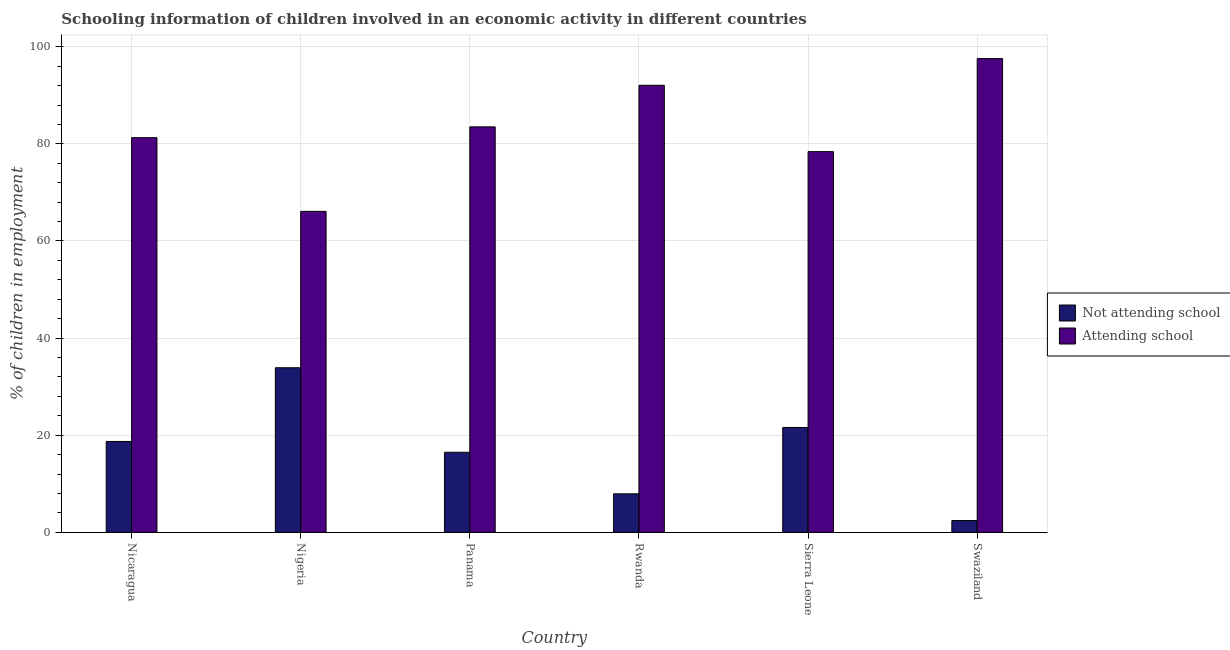How many different coloured bars are there?
Provide a succinct answer. 2. How many bars are there on the 2nd tick from the left?
Provide a short and direct response. 2. What is the label of the 4th group of bars from the left?
Offer a terse response. Rwanda. In how many cases, is the number of bars for a given country not equal to the number of legend labels?
Your answer should be very brief. 0. What is the percentage of employed children who are attending school in Nicaragua?
Keep it short and to the point. 81.27. Across all countries, what is the maximum percentage of employed children who are not attending school?
Offer a terse response. 33.9. Across all countries, what is the minimum percentage of employed children who are attending school?
Your response must be concise. 66.1. In which country was the percentage of employed children who are not attending school maximum?
Your answer should be compact. Nigeria. In which country was the percentage of employed children who are not attending school minimum?
Your answer should be very brief. Swaziland. What is the total percentage of employed children who are attending school in the graph?
Keep it short and to the point. 498.9. What is the difference between the percentage of employed children who are not attending school in Nicaragua and that in Sierra Leone?
Your answer should be compact. -2.87. What is the difference between the percentage of employed children who are not attending school in Sierra Leone and the percentage of employed children who are attending school in Panama?
Keep it short and to the point. -61.9. What is the average percentage of employed children who are attending school per country?
Give a very brief answer. 83.15. What is the difference between the percentage of employed children who are attending school and percentage of employed children who are not attending school in Nigeria?
Provide a short and direct response. 32.2. What is the ratio of the percentage of employed children who are not attending school in Nigeria to that in Sierra Leone?
Provide a short and direct response. 1.57. Is the percentage of employed children who are not attending school in Panama less than that in Swaziland?
Provide a succinct answer. No. Is the difference between the percentage of employed children who are attending school in Sierra Leone and Swaziland greater than the difference between the percentage of employed children who are not attending school in Sierra Leone and Swaziland?
Keep it short and to the point. No. What is the difference between the highest and the second highest percentage of employed children who are not attending school?
Your response must be concise. 12.3. What is the difference between the highest and the lowest percentage of employed children who are not attending school?
Your answer should be compact. 31.46. Is the sum of the percentage of employed children who are not attending school in Nicaragua and Swaziland greater than the maximum percentage of employed children who are attending school across all countries?
Offer a terse response. No. What does the 2nd bar from the left in Nicaragua represents?
Provide a succinct answer. Attending school. What does the 1st bar from the right in Nigeria represents?
Offer a terse response. Attending school. Are all the bars in the graph horizontal?
Give a very brief answer. No. How many countries are there in the graph?
Your answer should be compact. 6. Does the graph contain grids?
Offer a very short reply. Yes. Where does the legend appear in the graph?
Give a very brief answer. Center right. What is the title of the graph?
Your response must be concise. Schooling information of children involved in an economic activity in different countries. Does "Electricity and heat production" appear as one of the legend labels in the graph?
Ensure brevity in your answer.  No. What is the label or title of the X-axis?
Provide a short and direct response. Country. What is the label or title of the Y-axis?
Your answer should be compact. % of children in employment. What is the % of children in employment in Not attending school in Nicaragua?
Offer a terse response. 18.73. What is the % of children in employment of Attending school in Nicaragua?
Your answer should be very brief. 81.27. What is the % of children in employment of Not attending school in Nigeria?
Offer a very short reply. 33.9. What is the % of children in employment in Attending school in Nigeria?
Your answer should be compact. 66.1. What is the % of children in employment of Not attending school in Panama?
Provide a short and direct response. 16.5. What is the % of children in employment in Attending school in Panama?
Make the answer very short. 83.5. What is the % of children in employment in Not attending school in Rwanda?
Ensure brevity in your answer.  7.94. What is the % of children in employment of Attending school in Rwanda?
Provide a short and direct response. 92.06. What is the % of children in employment of Not attending school in Sierra Leone?
Provide a short and direct response. 21.6. What is the % of children in employment in Attending school in Sierra Leone?
Your answer should be compact. 78.4. What is the % of children in employment of Not attending school in Swaziland?
Provide a succinct answer. 2.44. What is the % of children in employment in Attending school in Swaziland?
Your answer should be compact. 97.56. Across all countries, what is the maximum % of children in employment in Not attending school?
Offer a very short reply. 33.9. Across all countries, what is the maximum % of children in employment of Attending school?
Your answer should be compact. 97.56. Across all countries, what is the minimum % of children in employment of Not attending school?
Your response must be concise. 2.44. Across all countries, what is the minimum % of children in employment in Attending school?
Offer a terse response. 66.1. What is the total % of children in employment of Not attending school in the graph?
Your answer should be very brief. 101.1. What is the total % of children in employment in Attending school in the graph?
Keep it short and to the point. 498.9. What is the difference between the % of children in employment in Not attending school in Nicaragua and that in Nigeria?
Your answer should be compact. -15.17. What is the difference between the % of children in employment of Attending school in Nicaragua and that in Nigeria?
Offer a terse response. 15.17. What is the difference between the % of children in employment of Not attending school in Nicaragua and that in Panama?
Your response must be concise. 2.23. What is the difference between the % of children in employment of Attending school in Nicaragua and that in Panama?
Provide a succinct answer. -2.23. What is the difference between the % of children in employment in Not attending school in Nicaragua and that in Rwanda?
Offer a very short reply. 10.79. What is the difference between the % of children in employment of Attending school in Nicaragua and that in Rwanda?
Give a very brief answer. -10.79. What is the difference between the % of children in employment of Not attending school in Nicaragua and that in Sierra Leone?
Offer a very short reply. -2.87. What is the difference between the % of children in employment in Attending school in Nicaragua and that in Sierra Leone?
Your answer should be very brief. 2.87. What is the difference between the % of children in employment in Not attending school in Nicaragua and that in Swaziland?
Your answer should be compact. 16.29. What is the difference between the % of children in employment of Attending school in Nicaragua and that in Swaziland?
Offer a terse response. -16.29. What is the difference between the % of children in employment of Not attending school in Nigeria and that in Panama?
Give a very brief answer. 17.4. What is the difference between the % of children in employment in Attending school in Nigeria and that in Panama?
Provide a short and direct response. -17.4. What is the difference between the % of children in employment of Not attending school in Nigeria and that in Rwanda?
Your answer should be compact. 25.96. What is the difference between the % of children in employment in Attending school in Nigeria and that in Rwanda?
Give a very brief answer. -25.96. What is the difference between the % of children in employment in Not attending school in Nigeria and that in Sierra Leone?
Make the answer very short. 12.3. What is the difference between the % of children in employment of Attending school in Nigeria and that in Sierra Leone?
Provide a short and direct response. -12.3. What is the difference between the % of children in employment of Not attending school in Nigeria and that in Swaziland?
Keep it short and to the point. 31.46. What is the difference between the % of children in employment of Attending school in Nigeria and that in Swaziland?
Ensure brevity in your answer.  -31.46. What is the difference between the % of children in employment of Not attending school in Panama and that in Rwanda?
Ensure brevity in your answer.  8.56. What is the difference between the % of children in employment of Attending school in Panama and that in Rwanda?
Make the answer very short. -8.56. What is the difference between the % of children in employment of Attending school in Panama and that in Sierra Leone?
Offer a very short reply. 5.1. What is the difference between the % of children in employment in Not attending school in Panama and that in Swaziland?
Your response must be concise. 14.06. What is the difference between the % of children in employment in Attending school in Panama and that in Swaziland?
Ensure brevity in your answer.  -14.06. What is the difference between the % of children in employment of Not attending school in Rwanda and that in Sierra Leone?
Keep it short and to the point. -13.66. What is the difference between the % of children in employment in Attending school in Rwanda and that in Sierra Leone?
Offer a terse response. 13.66. What is the difference between the % of children in employment in Not attending school in Rwanda and that in Swaziland?
Provide a short and direct response. 5.5. What is the difference between the % of children in employment in Attending school in Rwanda and that in Swaziland?
Your answer should be very brief. -5.5. What is the difference between the % of children in employment of Not attending school in Sierra Leone and that in Swaziland?
Make the answer very short. 19.16. What is the difference between the % of children in employment of Attending school in Sierra Leone and that in Swaziland?
Provide a short and direct response. -19.16. What is the difference between the % of children in employment of Not attending school in Nicaragua and the % of children in employment of Attending school in Nigeria?
Your answer should be compact. -47.37. What is the difference between the % of children in employment in Not attending school in Nicaragua and the % of children in employment in Attending school in Panama?
Ensure brevity in your answer.  -64.77. What is the difference between the % of children in employment of Not attending school in Nicaragua and the % of children in employment of Attending school in Rwanda?
Your answer should be very brief. -73.34. What is the difference between the % of children in employment in Not attending school in Nicaragua and the % of children in employment in Attending school in Sierra Leone?
Offer a very short reply. -59.67. What is the difference between the % of children in employment in Not attending school in Nicaragua and the % of children in employment in Attending school in Swaziland?
Give a very brief answer. -78.84. What is the difference between the % of children in employment in Not attending school in Nigeria and the % of children in employment in Attending school in Panama?
Your response must be concise. -49.6. What is the difference between the % of children in employment in Not attending school in Nigeria and the % of children in employment in Attending school in Rwanda?
Make the answer very short. -58.16. What is the difference between the % of children in employment of Not attending school in Nigeria and the % of children in employment of Attending school in Sierra Leone?
Ensure brevity in your answer.  -44.5. What is the difference between the % of children in employment in Not attending school in Nigeria and the % of children in employment in Attending school in Swaziland?
Make the answer very short. -63.66. What is the difference between the % of children in employment in Not attending school in Panama and the % of children in employment in Attending school in Rwanda?
Give a very brief answer. -75.56. What is the difference between the % of children in employment in Not attending school in Panama and the % of children in employment in Attending school in Sierra Leone?
Your answer should be very brief. -61.9. What is the difference between the % of children in employment of Not attending school in Panama and the % of children in employment of Attending school in Swaziland?
Offer a terse response. -81.06. What is the difference between the % of children in employment of Not attending school in Rwanda and the % of children in employment of Attending school in Sierra Leone?
Offer a very short reply. -70.46. What is the difference between the % of children in employment in Not attending school in Rwanda and the % of children in employment in Attending school in Swaziland?
Make the answer very short. -89.62. What is the difference between the % of children in employment in Not attending school in Sierra Leone and the % of children in employment in Attending school in Swaziland?
Make the answer very short. -75.96. What is the average % of children in employment in Not attending school per country?
Provide a succinct answer. 16.85. What is the average % of children in employment in Attending school per country?
Make the answer very short. 83.15. What is the difference between the % of children in employment of Not attending school and % of children in employment of Attending school in Nicaragua?
Your answer should be compact. -62.55. What is the difference between the % of children in employment in Not attending school and % of children in employment in Attending school in Nigeria?
Your answer should be compact. -32.2. What is the difference between the % of children in employment in Not attending school and % of children in employment in Attending school in Panama?
Give a very brief answer. -67. What is the difference between the % of children in employment of Not attending school and % of children in employment of Attending school in Rwanda?
Your answer should be very brief. -84.12. What is the difference between the % of children in employment in Not attending school and % of children in employment in Attending school in Sierra Leone?
Make the answer very short. -56.8. What is the difference between the % of children in employment in Not attending school and % of children in employment in Attending school in Swaziland?
Make the answer very short. -95.13. What is the ratio of the % of children in employment in Not attending school in Nicaragua to that in Nigeria?
Keep it short and to the point. 0.55. What is the ratio of the % of children in employment of Attending school in Nicaragua to that in Nigeria?
Offer a very short reply. 1.23. What is the ratio of the % of children in employment in Not attending school in Nicaragua to that in Panama?
Offer a very short reply. 1.13. What is the ratio of the % of children in employment of Attending school in Nicaragua to that in Panama?
Offer a very short reply. 0.97. What is the ratio of the % of children in employment in Not attending school in Nicaragua to that in Rwanda?
Give a very brief answer. 2.36. What is the ratio of the % of children in employment of Attending school in Nicaragua to that in Rwanda?
Provide a short and direct response. 0.88. What is the ratio of the % of children in employment in Not attending school in Nicaragua to that in Sierra Leone?
Provide a succinct answer. 0.87. What is the ratio of the % of children in employment in Attending school in Nicaragua to that in Sierra Leone?
Make the answer very short. 1.04. What is the ratio of the % of children in employment in Not attending school in Nicaragua to that in Swaziland?
Ensure brevity in your answer.  7.69. What is the ratio of the % of children in employment in Attending school in Nicaragua to that in Swaziland?
Give a very brief answer. 0.83. What is the ratio of the % of children in employment in Not attending school in Nigeria to that in Panama?
Give a very brief answer. 2.05. What is the ratio of the % of children in employment in Attending school in Nigeria to that in Panama?
Give a very brief answer. 0.79. What is the ratio of the % of children in employment in Not attending school in Nigeria to that in Rwanda?
Offer a terse response. 4.27. What is the ratio of the % of children in employment of Attending school in Nigeria to that in Rwanda?
Offer a very short reply. 0.72. What is the ratio of the % of children in employment in Not attending school in Nigeria to that in Sierra Leone?
Make the answer very short. 1.57. What is the ratio of the % of children in employment of Attending school in Nigeria to that in Sierra Leone?
Ensure brevity in your answer.  0.84. What is the ratio of the % of children in employment in Not attending school in Nigeria to that in Swaziland?
Your response must be concise. 13.91. What is the ratio of the % of children in employment in Attending school in Nigeria to that in Swaziland?
Your answer should be compact. 0.68. What is the ratio of the % of children in employment of Not attending school in Panama to that in Rwanda?
Keep it short and to the point. 2.08. What is the ratio of the % of children in employment in Attending school in Panama to that in Rwanda?
Your response must be concise. 0.91. What is the ratio of the % of children in employment in Not attending school in Panama to that in Sierra Leone?
Your answer should be compact. 0.76. What is the ratio of the % of children in employment of Attending school in Panama to that in Sierra Leone?
Your response must be concise. 1.07. What is the ratio of the % of children in employment in Not attending school in Panama to that in Swaziland?
Provide a succinct answer. 6.77. What is the ratio of the % of children in employment in Attending school in Panama to that in Swaziland?
Offer a terse response. 0.86. What is the ratio of the % of children in employment of Not attending school in Rwanda to that in Sierra Leone?
Keep it short and to the point. 0.37. What is the ratio of the % of children in employment in Attending school in Rwanda to that in Sierra Leone?
Offer a very short reply. 1.17. What is the ratio of the % of children in employment in Not attending school in Rwanda to that in Swaziland?
Offer a very short reply. 3.26. What is the ratio of the % of children in employment of Attending school in Rwanda to that in Swaziland?
Offer a very short reply. 0.94. What is the ratio of the % of children in employment of Not attending school in Sierra Leone to that in Swaziland?
Provide a short and direct response. 8.87. What is the ratio of the % of children in employment of Attending school in Sierra Leone to that in Swaziland?
Ensure brevity in your answer.  0.8. What is the difference between the highest and the second highest % of children in employment in Attending school?
Provide a short and direct response. 5.5. What is the difference between the highest and the lowest % of children in employment of Not attending school?
Keep it short and to the point. 31.46. What is the difference between the highest and the lowest % of children in employment of Attending school?
Make the answer very short. 31.46. 